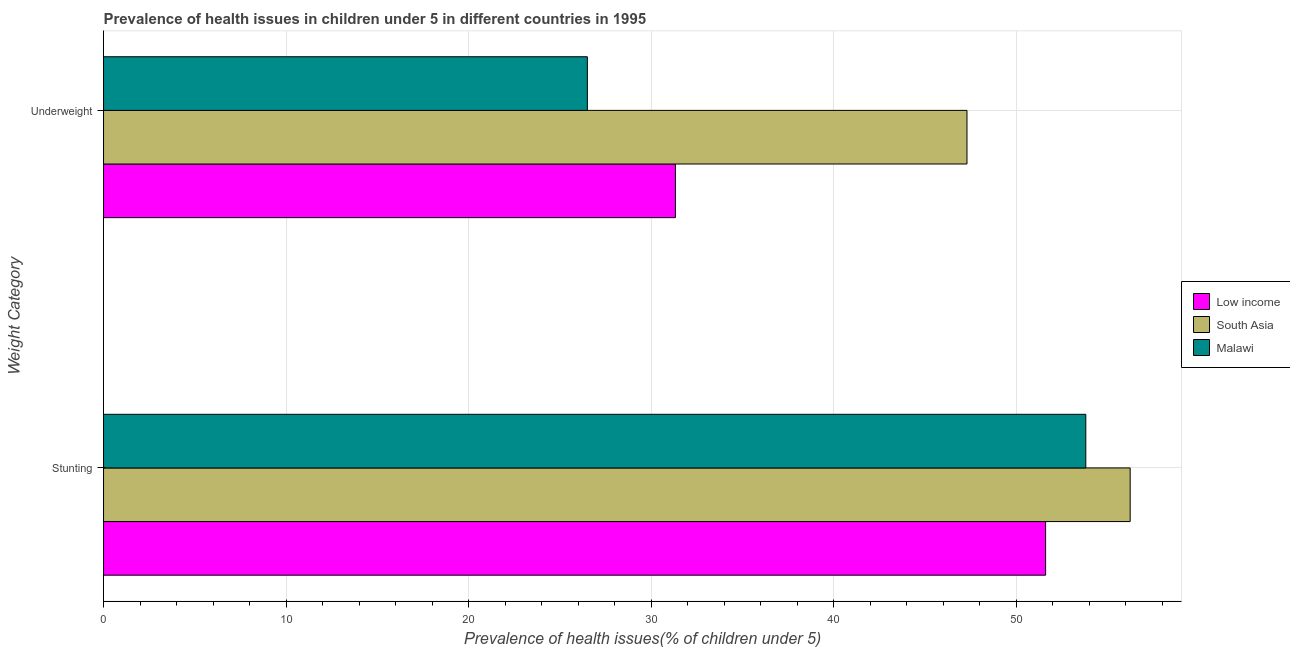How many different coloured bars are there?
Make the answer very short. 3. How many groups of bars are there?
Ensure brevity in your answer.  2. Are the number of bars per tick equal to the number of legend labels?
Your answer should be very brief. Yes. How many bars are there on the 1st tick from the top?
Your response must be concise. 3. What is the label of the 1st group of bars from the top?
Keep it short and to the point. Underweight. What is the percentage of stunted children in South Asia?
Offer a very short reply. 56.23. Across all countries, what is the maximum percentage of stunted children?
Ensure brevity in your answer.  56.23. Across all countries, what is the minimum percentage of stunted children?
Offer a very short reply. 51.6. In which country was the percentage of underweight children minimum?
Make the answer very short. Malawi. What is the total percentage of underweight children in the graph?
Make the answer very short. 105.12. What is the difference between the percentage of underweight children in South Asia and that in Malawi?
Offer a terse response. 20.79. What is the difference between the percentage of underweight children in Low income and the percentage of stunted children in South Asia?
Provide a short and direct response. -24.91. What is the average percentage of underweight children per country?
Ensure brevity in your answer.  35.04. What is the difference between the percentage of stunted children and percentage of underweight children in Low income?
Offer a terse response. 20.28. In how many countries, is the percentage of stunted children greater than 50 %?
Keep it short and to the point. 3. What is the ratio of the percentage of underweight children in Low income to that in Malawi?
Keep it short and to the point. 1.18. Is the percentage of underweight children in Malawi less than that in Low income?
Offer a very short reply. Yes. What does the 2nd bar from the top in Underweight represents?
Your answer should be compact. South Asia. What does the 3rd bar from the bottom in Underweight represents?
Provide a short and direct response. Malawi. How many countries are there in the graph?
Provide a short and direct response. 3. What is the difference between two consecutive major ticks on the X-axis?
Ensure brevity in your answer.  10. Does the graph contain any zero values?
Your response must be concise. No. Does the graph contain grids?
Offer a very short reply. Yes. Where does the legend appear in the graph?
Ensure brevity in your answer.  Center right. How many legend labels are there?
Offer a terse response. 3. What is the title of the graph?
Ensure brevity in your answer.  Prevalence of health issues in children under 5 in different countries in 1995. What is the label or title of the X-axis?
Ensure brevity in your answer.  Prevalence of health issues(% of children under 5). What is the label or title of the Y-axis?
Keep it short and to the point. Weight Category. What is the Prevalence of health issues(% of children under 5) in Low income in Stunting?
Offer a very short reply. 51.6. What is the Prevalence of health issues(% of children under 5) of South Asia in Stunting?
Offer a very short reply. 56.23. What is the Prevalence of health issues(% of children under 5) in Malawi in Stunting?
Offer a very short reply. 53.8. What is the Prevalence of health issues(% of children under 5) in Low income in Underweight?
Provide a short and direct response. 31.32. What is the Prevalence of health issues(% of children under 5) in South Asia in Underweight?
Provide a succinct answer. 47.29. What is the Prevalence of health issues(% of children under 5) in Malawi in Underweight?
Offer a very short reply. 26.5. Across all Weight Category, what is the maximum Prevalence of health issues(% of children under 5) in Low income?
Provide a succinct answer. 51.6. Across all Weight Category, what is the maximum Prevalence of health issues(% of children under 5) of South Asia?
Give a very brief answer. 56.23. Across all Weight Category, what is the maximum Prevalence of health issues(% of children under 5) of Malawi?
Keep it short and to the point. 53.8. Across all Weight Category, what is the minimum Prevalence of health issues(% of children under 5) in Low income?
Keep it short and to the point. 31.32. Across all Weight Category, what is the minimum Prevalence of health issues(% of children under 5) in South Asia?
Provide a short and direct response. 47.29. Across all Weight Category, what is the minimum Prevalence of health issues(% of children under 5) in Malawi?
Your response must be concise. 26.5. What is the total Prevalence of health issues(% of children under 5) of Low income in the graph?
Make the answer very short. 82.92. What is the total Prevalence of health issues(% of children under 5) of South Asia in the graph?
Keep it short and to the point. 103.52. What is the total Prevalence of health issues(% of children under 5) of Malawi in the graph?
Offer a very short reply. 80.3. What is the difference between the Prevalence of health issues(% of children under 5) of Low income in Stunting and that in Underweight?
Ensure brevity in your answer.  20.28. What is the difference between the Prevalence of health issues(% of children under 5) of South Asia in Stunting and that in Underweight?
Give a very brief answer. 8.94. What is the difference between the Prevalence of health issues(% of children under 5) of Malawi in Stunting and that in Underweight?
Make the answer very short. 27.3. What is the difference between the Prevalence of health issues(% of children under 5) in Low income in Stunting and the Prevalence of health issues(% of children under 5) in South Asia in Underweight?
Provide a succinct answer. 4.31. What is the difference between the Prevalence of health issues(% of children under 5) of Low income in Stunting and the Prevalence of health issues(% of children under 5) of Malawi in Underweight?
Give a very brief answer. 25.1. What is the difference between the Prevalence of health issues(% of children under 5) in South Asia in Stunting and the Prevalence of health issues(% of children under 5) in Malawi in Underweight?
Your answer should be compact. 29.73. What is the average Prevalence of health issues(% of children under 5) of Low income per Weight Category?
Your answer should be very brief. 41.46. What is the average Prevalence of health issues(% of children under 5) of South Asia per Weight Category?
Offer a very short reply. 51.76. What is the average Prevalence of health issues(% of children under 5) of Malawi per Weight Category?
Provide a succinct answer. 40.15. What is the difference between the Prevalence of health issues(% of children under 5) in Low income and Prevalence of health issues(% of children under 5) in South Asia in Stunting?
Ensure brevity in your answer.  -4.63. What is the difference between the Prevalence of health issues(% of children under 5) of Low income and Prevalence of health issues(% of children under 5) of Malawi in Stunting?
Your answer should be very brief. -2.2. What is the difference between the Prevalence of health issues(% of children under 5) in South Asia and Prevalence of health issues(% of children under 5) in Malawi in Stunting?
Keep it short and to the point. 2.43. What is the difference between the Prevalence of health issues(% of children under 5) of Low income and Prevalence of health issues(% of children under 5) of South Asia in Underweight?
Your answer should be compact. -15.97. What is the difference between the Prevalence of health issues(% of children under 5) of Low income and Prevalence of health issues(% of children under 5) of Malawi in Underweight?
Provide a succinct answer. 4.82. What is the difference between the Prevalence of health issues(% of children under 5) of South Asia and Prevalence of health issues(% of children under 5) of Malawi in Underweight?
Give a very brief answer. 20.79. What is the ratio of the Prevalence of health issues(% of children under 5) of Low income in Stunting to that in Underweight?
Your response must be concise. 1.65. What is the ratio of the Prevalence of health issues(% of children under 5) of South Asia in Stunting to that in Underweight?
Make the answer very short. 1.19. What is the ratio of the Prevalence of health issues(% of children under 5) in Malawi in Stunting to that in Underweight?
Give a very brief answer. 2.03. What is the difference between the highest and the second highest Prevalence of health issues(% of children under 5) in Low income?
Make the answer very short. 20.28. What is the difference between the highest and the second highest Prevalence of health issues(% of children under 5) of South Asia?
Give a very brief answer. 8.94. What is the difference between the highest and the second highest Prevalence of health issues(% of children under 5) of Malawi?
Your answer should be compact. 27.3. What is the difference between the highest and the lowest Prevalence of health issues(% of children under 5) of Low income?
Your answer should be very brief. 20.28. What is the difference between the highest and the lowest Prevalence of health issues(% of children under 5) of South Asia?
Your answer should be compact. 8.94. What is the difference between the highest and the lowest Prevalence of health issues(% of children under 5) in Malawi?
Ensure brevity in your answer.  27.3. 